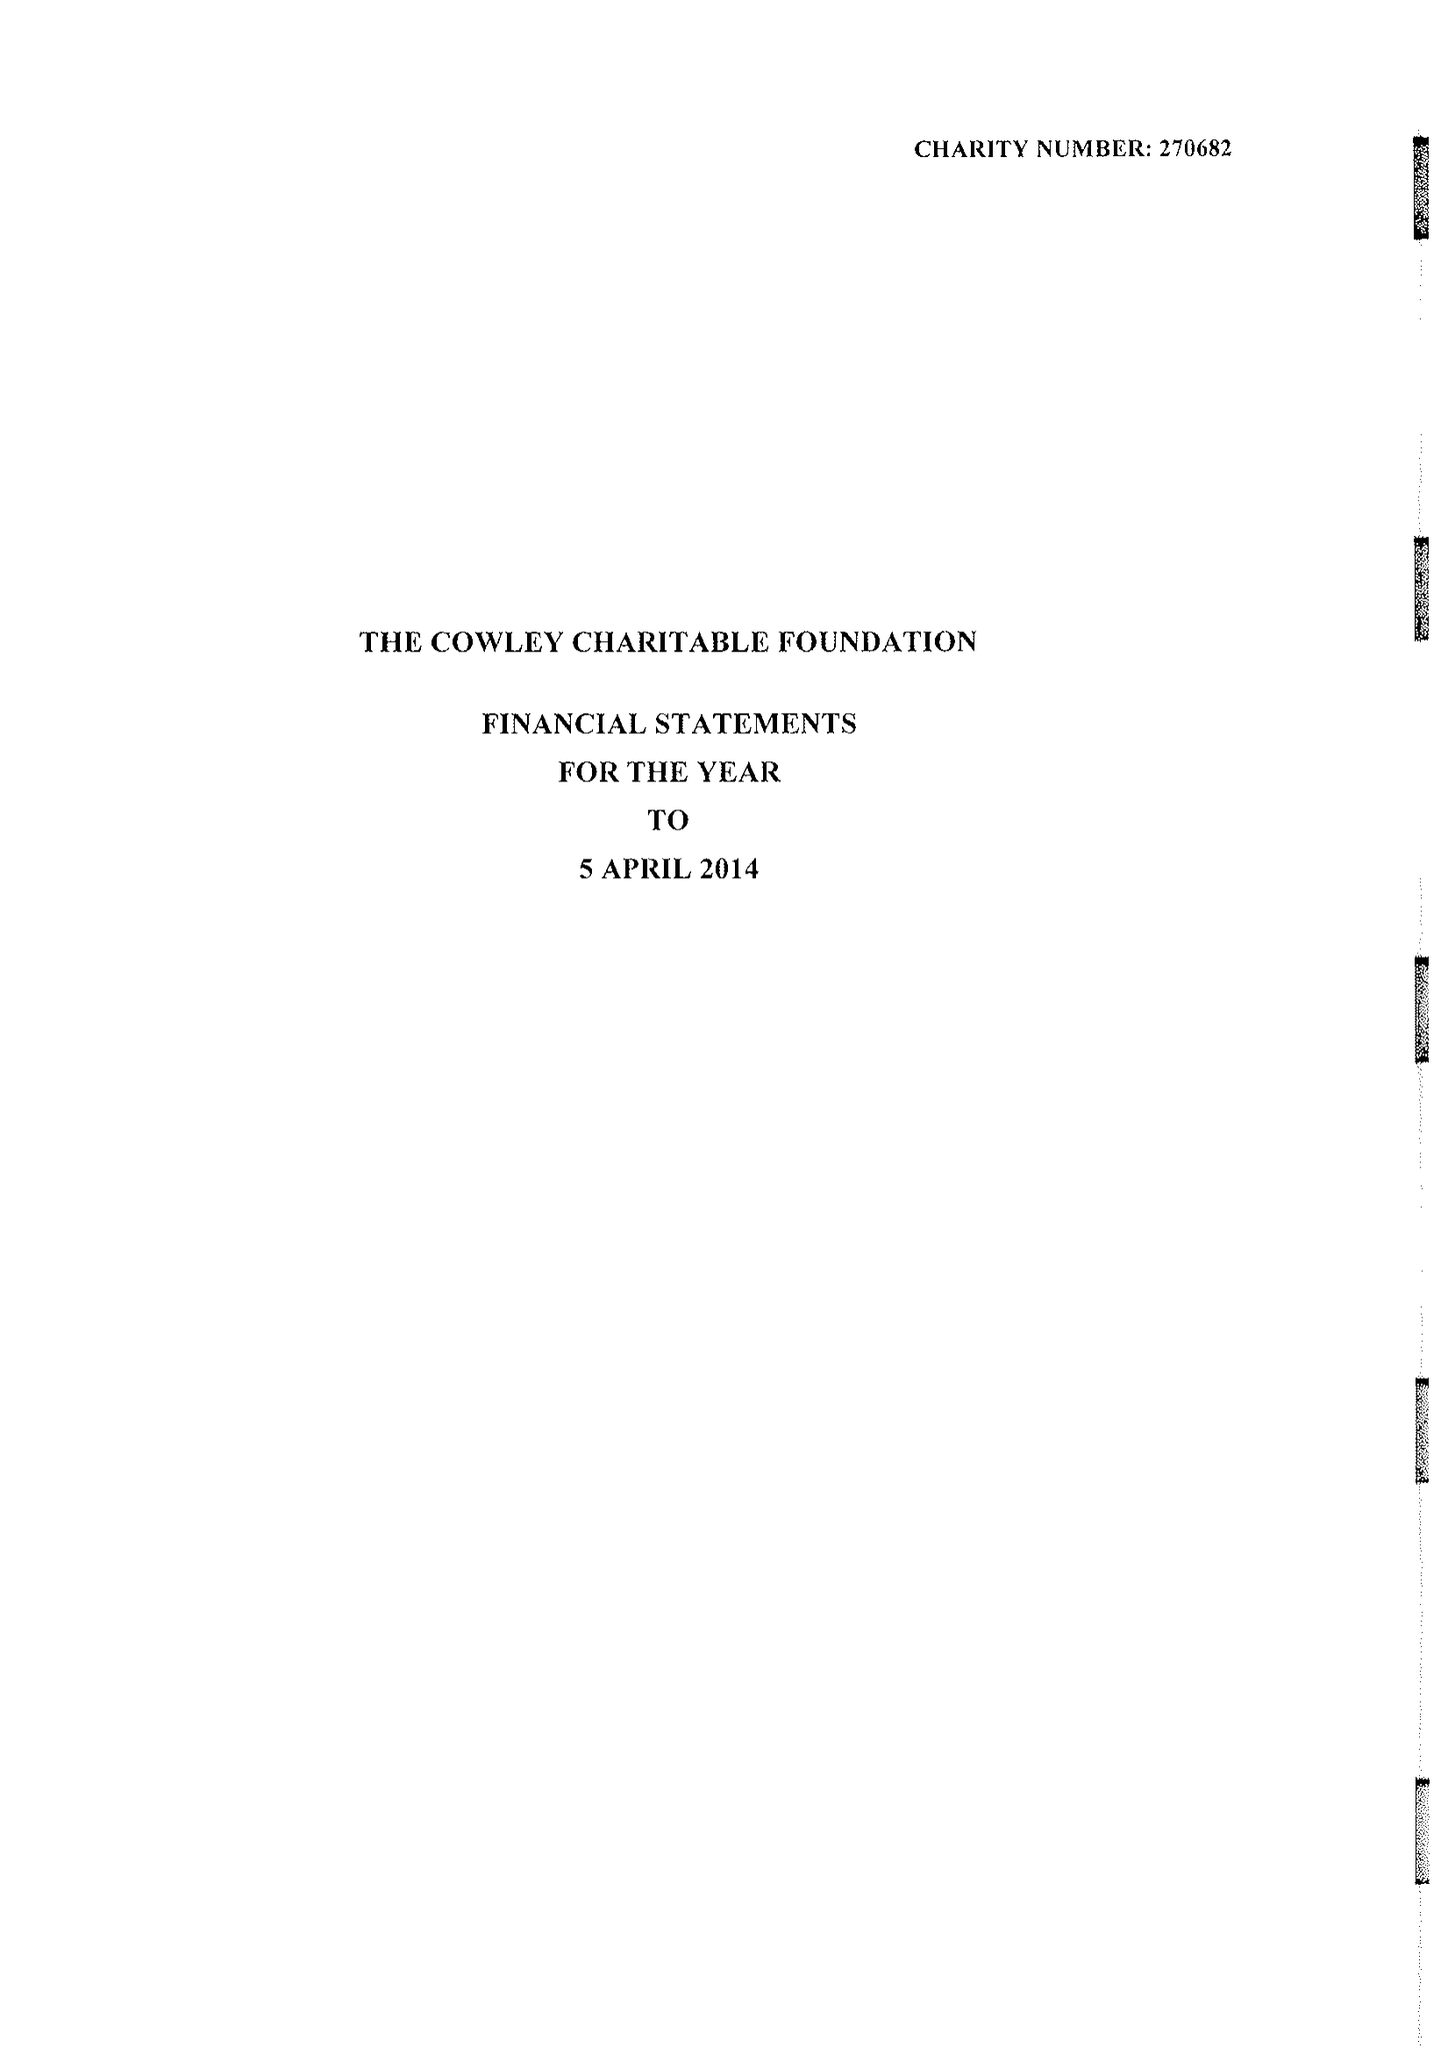What is the value for the charity_number?
Answer the question using a single word or phrase. 270682 